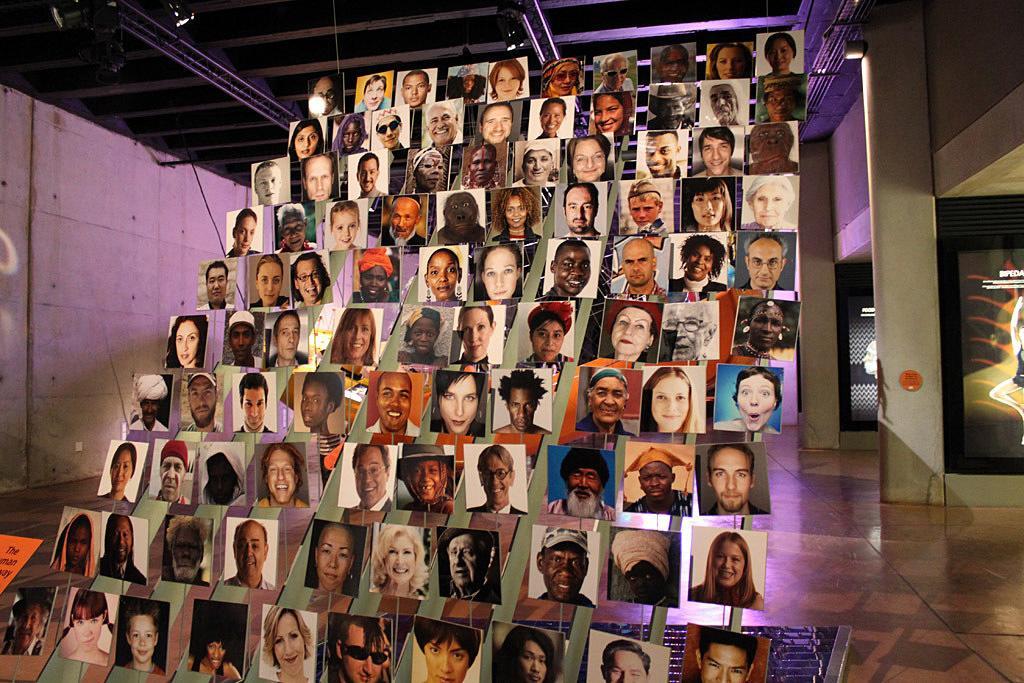Could you give a brief overview of what you see in this image? In this image I can see photos of people. In the background I can see a wall and some objects attached to the wall. 